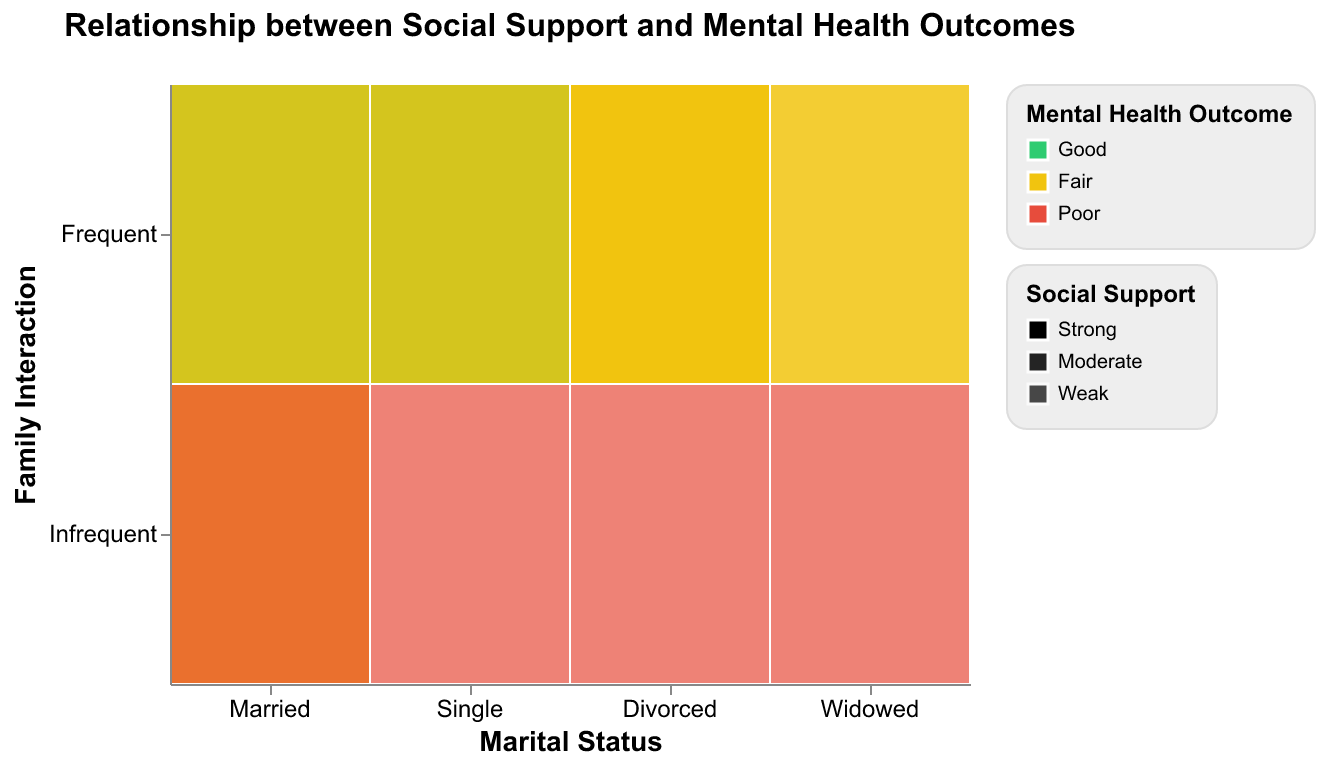What is the title of the plot? The title is always positioned prominently at the top center of a plot. Here, we see the title presented as "Relationship between Social Support and Mental Health Outcomes".
Answer: Relationship between Social Support and Mental Health Outcomes Which marital status group shows the highest percentage of "Good" mental health outcomes? To determine this, locate the segments representing "Good" mental health outcomes, which are colored green. Compare their heights across different marital statuses.
Answer: Married group What color is used to represent "Poor" mental health outcomes? The plot uses colors to differentiate mental health outcomes. By identifying the color corresponding to the label "Poor" in the legend, we see that it's represented in red.
Answer: Red How does the frequency of family interaction seem to impact mental health outcomes for first responders? Observe the differences in mental health outcome colors for different family interaction frequencies. Frequent interactions typically show stronger greens and yellows, indicating better mental health outcomes compared to infrequent interactions.
Answer: Frequent interactions show better mental health outcomes Which marital status has a higher percentage of "Weak" social support within those who interact infrequently with family? Look at the segments with "Weak" social support (most transparent) for infrequent interactions within each marital status. Compare the segment heights.
Answer: Divorced and Widowed What is the relationship between social support and mental health outcomes for single first responders? Analyze the colors and opacities associated with social support levels for single first responders. Single first responders with strong social support tend to have good mental health outcomes (green), while those with weak support often have poor outcomes (red).
Answer: Strong support usually means good outcomes, weak support means poor outcomes Between married and single first responders, who is more likely to report "Fair" mental health outcomes with frequent family interactions? Compare the segments indicating "Fair" mental health outcomes (yellow) within the married and single categories for frequent family interactions. The married category has more yellow segments, indicating a higher likelihood of "Fair" outcomes.
Answer: Married first responders What is the most common social support level among widowed first responders? Examine the opacities allocated to widowed first responders in different segments. Notice that the most frequent or prominent opacity level represents moderate social support.
Answer: Weak Do frequent family interactions correlate with stronger social support for all marital statuses? Check the segments under frequent family interactions for each marital status and see if they possess higher opacities (representing stronger support). This trend is more evident in categories like Married and Single, but not universally.
Answer: Generally yes, but not universally 